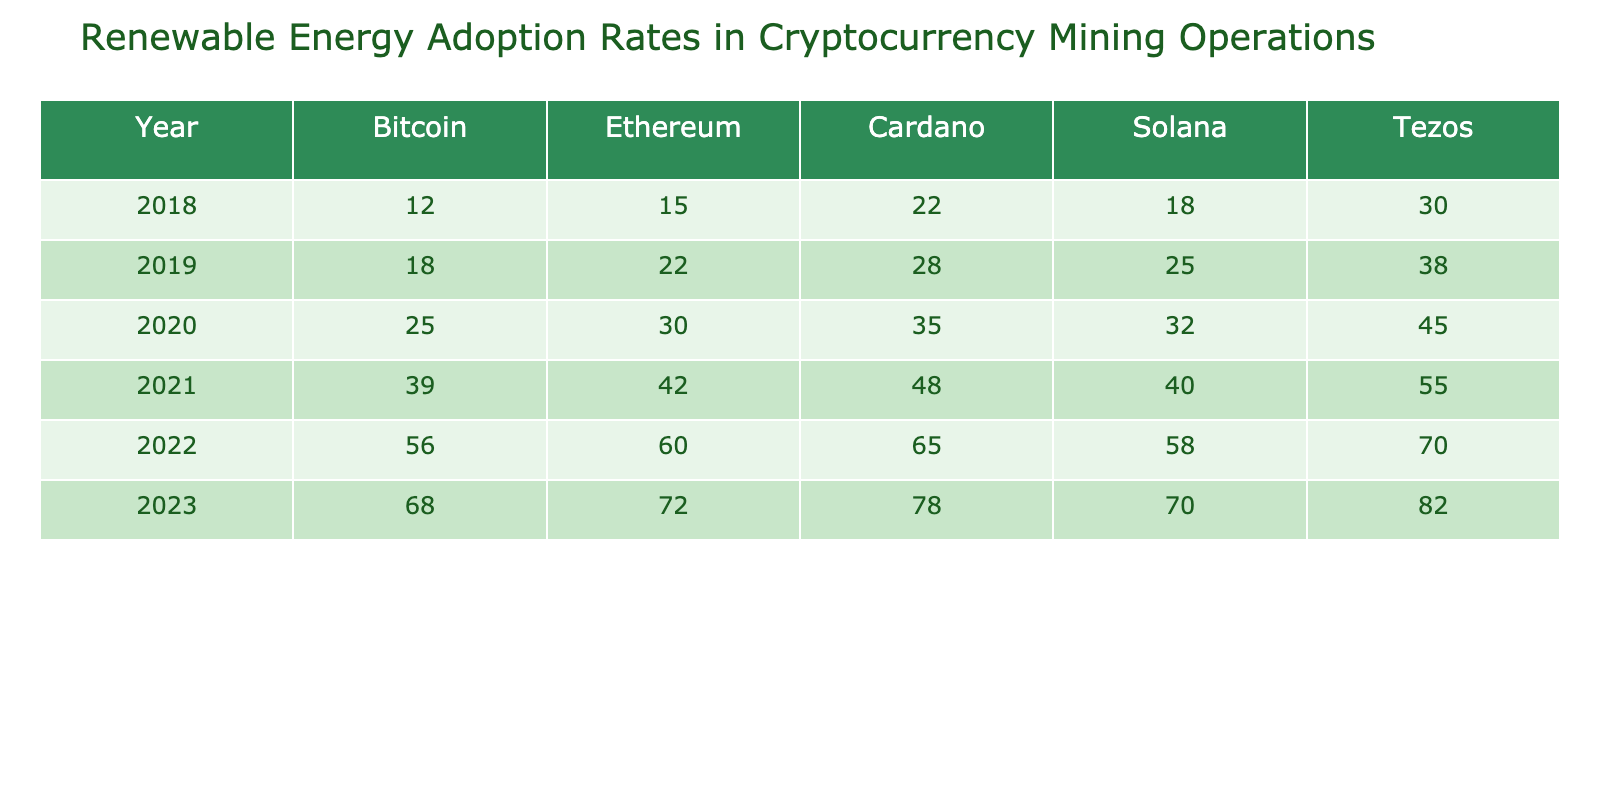What was the adoption rate of Bitcoin in 2020? The value for Bitcoin in the year 2020 is directly listed in the table as 25.
Answer: 25 What is the adoption rate of Solana in 2023? The value for Solana in 2023 is directly provided in the table, which is 70.
Answer: 70 Which cryptocurrency had the highest adoption rate in 2022? By comparing the values for each cryptocurrency in 2022, Tezos has the highest value at 70.
Answer: Tezos What was the percentage increase of Ethereum adoption from 2020 to 2021? The value for Ethereum in 2020 is 30 and in 2021 is 42. The percentage increase is calculated as ((42 - 30) / 30) * 100 = 40%.
Answer: 40% What is the average adoption rate of Cardano from 2018 to 2023? The values for Cardano from 2018 to 2023 are 22, 28, 35, 48, 65, and 78. The total sum is 22 + 28 + 35 + 48 + 65 + 78 = 276. There are 6 values, so the average is 276 / 6 = 46.
Answer: 46 Did the adoption rate of Bitcoin ever exceed 50%? Looking at the table values for Bitcoin, the values for the years 2018 to 2023 show Bitcoin exceeded 50% starting from 2022, with a value of 56.
Answer: Yes What is the difference in adoption rates between Ethereum and Tezos in 2021? In 2021, Ethereum has a value of 42, and Tezos has a value of 55. The difference is calculated as 55 - 42 = 13.
Answer: 13 Which cryptocurrency had the lowest adoption rate in 2019? By examining the values for all cryptocurrencies in 2019, Bitcoin has the lowest rate at 18.
Answer: Bitcoin What was the total adoption rate of all cryptocurrencies in 2022? The total adoption rate for 2022 is the sum of the individual rates: 56 (Bitcoin) + 60 (Ethereum) + 65 (Cardano) + 58 (Solana) + 70 (Tezos) = 309.
Answer: 309 What can you say about the trend of renewable energy adoption in cryptocurrency mining from 2018 to 2023? By analyzing the table, we see a consistent upward trend across all cryptocurrencies, indicating increasing adoption rates each year.
Answer: Increasing trend 